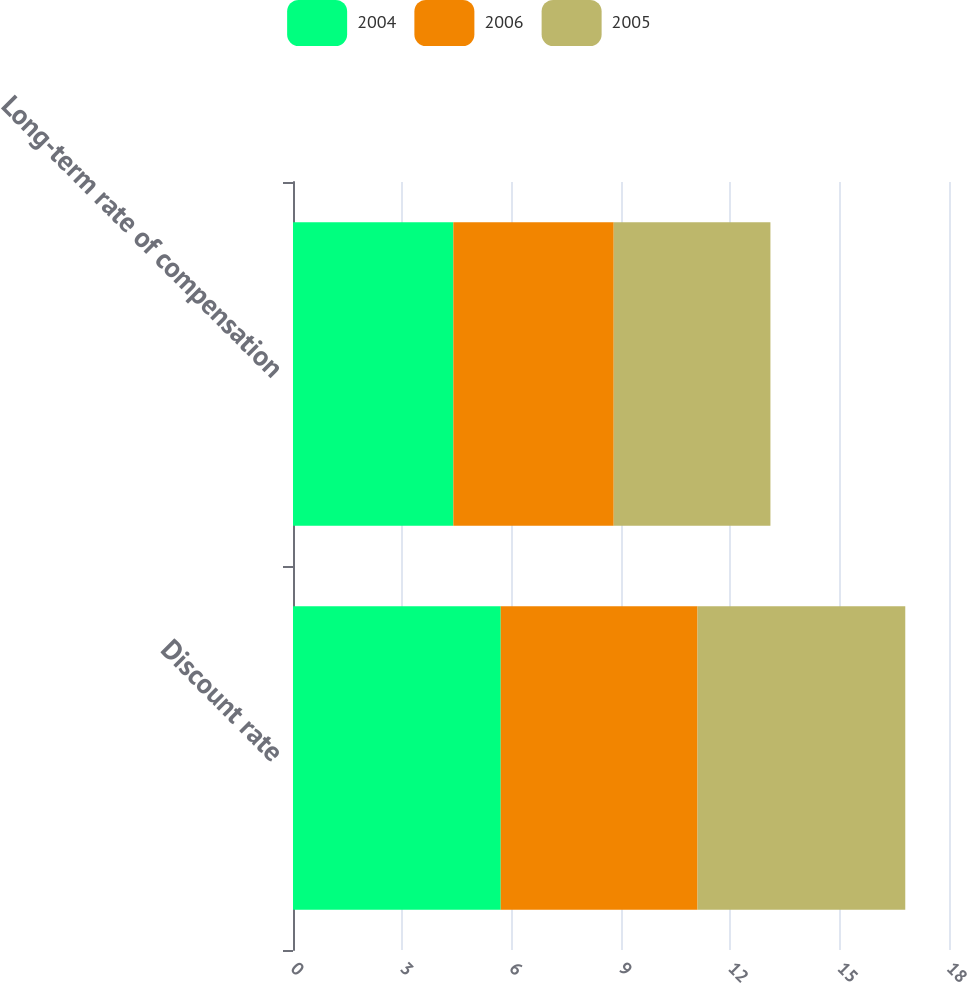<chart> <loc_0><loc_0><loc_500><loc_500><stacked_bar_chart><ecel><fcel>Discount rate<fcel>Long-term rate of compensation<nl><fcel>2004<fcel>5.7<fcel>4.4<nl><fcel>2006<fcel>5.4<fcel>4.4<nl><fcel>2005<fcel>5.7<fcel>4.3<nl></chart> 